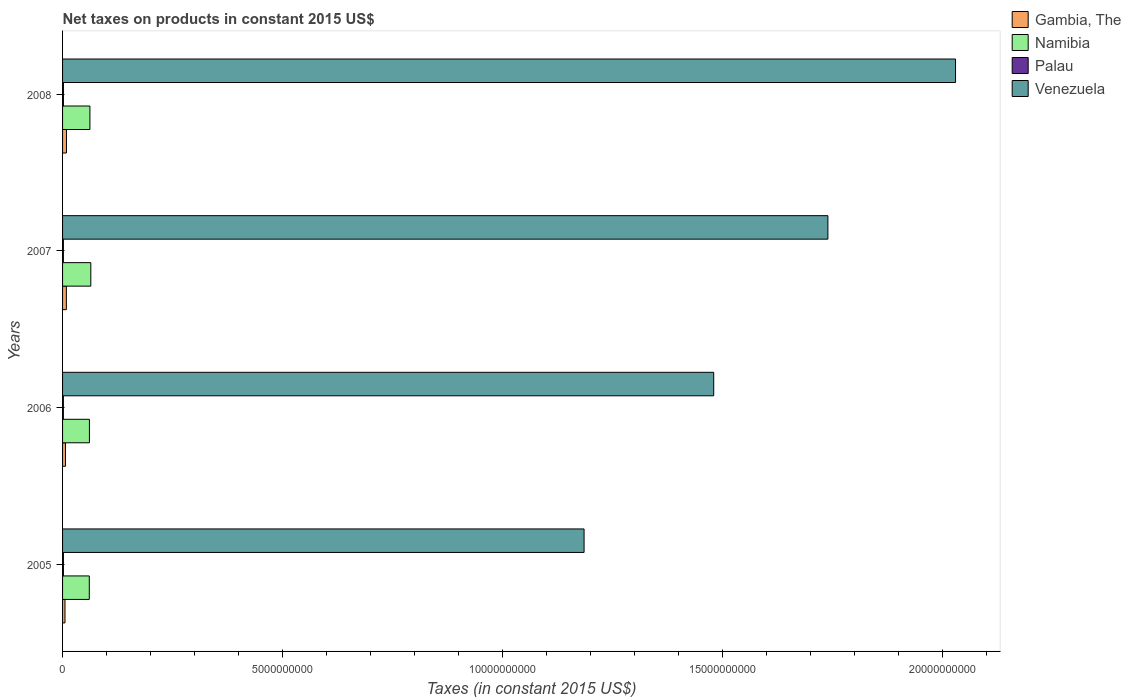How many groups of bars are there?
Ensure brevity in your answer.  4. Are the number of bars per tick equal to the number of legend labels?
Your answer should be very brief. Yes. How many bars are there on the 4th tick from the bottom?
Your answer should be very brief. 4. What is the label of the 2nd group of bars from the top?
Make the answer very short. 2007. What is the net taxes on products in Namibia in 2005?
Offer a very short reply. 6.08e+08. Across all years, what is the maximum net taxes on products in Venezuela?
Offer a terse response. 2.03e+1. Across all years, what is the minimum net taxes on products in Gambia, The?
Make the answer very short. 5.48e+07. What is the total net taxes on products in Gambia, The in the graph?
Offer a very short reply. 2.97e+08. What is the difference between the net taxes on products in Venezuela in 2007 and that in 2008?
Your answer should be compact. -2.90e+09. What is the difference between the net taxes on products in Venezuela in 2006 and the net taxes on products in Namibia in 2007?
Offer a terse response. 1.42e+1. What is the average net taxes on products in Namibia per year?
Keep it short and to the point. 6.20e+08. In the year 2007, what is the difference between the net taxes on products in Gambia, The and net taxes on products in Venezuela?
Give a very brief answer. -1.73e+1. What is the ratio of the net taxes on products in Venezuela in 2006 to that in 2008?
Offer a very short reply. 0.73. What is the difference between the highest and the second highest net taxes on products in Venezuela?
Give a very brief answer. 2.90e+09. What is the difference between the highest and the lowest net taxes on products in Venezuela?
Make the answer very short. 8.44e+09. In how many years, is the net taxes on products in Venezuela greater than the average net taxes on products in Venezuela taken over all years?
Make the answer very short. 2. Is the sum of the net taxes on products in Namibia in 2005 and 2006 greater than the maximum net taxes on products in Venezuela across all years?
Give a very brief answer. No. What does the 1st bar from the top in 2007 represents?
Your answer should be compact. Venezuela. What does the 3rd bar from the bottom in 2005 represents?
Keep it short and to the point. Palau. Is it the case that in every year, the sum of the net taxes on products in Gambia, The and net taxes on products in Palau is greater than the net taxes on products in Venezuela?
Offer a very short reply. No. How many bars are there?
Keep it short and to the point. 16. How many years are there in the graph?
Give a very brief answer. 4. What is the difference between two consecutive major ticks on the X-axis?
Your response must be concise. 5.00e+09. Are the values on the major ticks of X-axis written in scientific E-notation?
Provide a succinct answer. No. Where does the legend appear in the graph?
Provide a short and direct response. Top right. How many legend labels are there?
Offer a very short reply. 4. How are the legend labels stacked?
Provide a succinct answer. Vertical. What is the title of the graph?
Give a very brief answer. Net taxes on products in constant 2015 US$. Does "Jordan" appear as one of the legend labels in the graph?
Provide a short and direct response. No. What is the label or title of the X-axis?
Keep it short and to the point. Taxes (in constant 2015 US$). What is the Taxes (in constant 2015 US$) of Gambia, The in 2005?
Provide a short and direct response. 5.48e+07. What is the Taxes (in constant 2015 US$) of Namibia in 2005?
Make the answer very short. 6.08e+08. What is the Taxes (in constant 2015 US$) of Palau in 2005?
Your answer should be very brief. 1.94e+07. What is the Taxes (in constant 2015 US$) in Venezuela in 2005?
Offer a terse response. 1.19e+1. What is the Taxes (in constant 2015 US$) in Gambia, The in 2006?
Offer a very short reply. 6.61e+07. What is the Taxes (in constant 2015 US$) in Namibia in 2006?
Your answer should be very brief. 6.10e+08. What is the Taxes (in constant 2015 US$) of Palau in 2006?
Ensure brevity in your answer.  1.84e+07. What is the Taxes (in constant 2015 US$) in Venezuela in 2006?
Ensure brevity in your answer.  1.48e+1. What is the Taxes (in constant 2015 US$) in Gambia, The in 2007?
Ensure brevity in your answer.  8.66e+07. What is the Taxes (in constant 2015 US$) of Namibia in 2007?
Make the answer very short. 6.42e+08. What is the Taxes (in constant 2015 US$) of Palau in 2007?
Offer a terse response. 1.86e+07. What is the Taxes (in constant 2015 US$) of Venezuela in 2007?
Provide a succinct answer. 1.74e+1. What is the Taxes (in constant 2015 US$) of Gambia, The in 2008?
Provide a short and direct response. 8.92e+07. What is the Taxes (in constant 2015 US$) of Namibia in 2008?
Your answer should be very brief. 6.22e+08. What is the Taxes (in constant 2015 US$) of Palau in 2008?
Provide a short and direct response. 1.99e+07. What is the Taxes (in constant 2015 US$) in Venezuela in 2008?
Your response must be concise. 2.03e+1. Across all years, what is the maximum Taxes (in constant 2015 US$) in Gambia, The?
Your answer should be compact. 8.92e+07. Across all years, what is the maximum Taxes (in constant 2015 US$) in Namibia?
Offer a very short reply. 6.42e+08. Across all years, what is the maximum Taxes (in constant 2015 US$) of Palau?
Keep it short and to the point. 1.99e+07. Across all years, what is the maximum Taxes (in constant 2015 US$) in Venezuela?
Your response must be concise. 2.03e+1. Across all years, what is the minimum Taxes (in constant 2015 US$) in Gambia, The?
Your response must be concise. 5.48e+07. Across all years, what is the minimum Taxes (in constant 2015 US$) of Namibia?
Make the answer very short. 6.08e+08. Across all years, what is the minimum Taxes (in constant 2015 US$) in Palau?
Make the answer very short. 1.84e+07. Across all years, what is the minimum Taxes (in constant 2015 US$) of Venezuela?
Provide a succinct answer. 1.19e+1. What is the total Taxes (in constant 2015 US$) of Gambia, The in the graph?
Your answer should be compact. 2.97e+08. What is the total Taxes (in constant 2015 US$) in Namibia in the graph?
Offer a terse response. 2.48e+09. What is the total Taxes (in constant 2015 US$) of Palau in the graph?
Offer a very short reply. 7.63e+07. What is the total Taxes (in constant 2015 US$) of Venezuela in the graph?
Offer a terse response. 6.43e+1. What is the difference between the Taxes (in constant 2015 US$) of Gambia, The in 2005 and that in 2006?
Make the answer very short. -1.13e+07. What is the difference between the Taxes (in constant 2015 US$) of Namibia in 2005 and that in 2006?
Offer a very short reply. -2.85e+06. What is the difference between the Taxes (in constant 2015 US$) of Palau in 2005 and that in 2006?
Ensure brevity in your answer.  1.05e+06. What is the difference between the Taxes (in constant 2015 US$) in Venezuela in 2005 and that in 2006?
Ensure brevity in your answer.  -2.95e+09. What is the difference between the Taxes (in constant 2015 US$) in Gambia, The in 2005 and that in 2007?
Offer a terse response. -3.18e+07. What is the difference between the Taxes (in constant 2015 US$) in Namibia in 2005 and that in 2007?
Give a very brief answer. -3.43e+07. What is the difference between the Taxes (in constant 2015 US$) in Palau in 2005 and that in 2007?
Give a very brief answer. 8.20e+05. What is the difference between the Taxes (in constant 2015 US$) in Venezuela in 2005 and that in 2007?
Ensure brevity in your answer.  -5.54e+09. What is the difference between the Taxes (in constant 2015 US$) of Gambia, The in 2005 and that in 2008?
Make the answer very short. -3.44e+07. What is the difference between the Taxes (in constant 2015 US$) in Namibia in 2005 and that in 2008?
Your answer should be compact. -1.43e+07. What is the difference between the Taxes (in constant 2015 US$) in Palau in 2005 and that in 2008?
Give a very brief answer. -4.28e+05. What is the difference between the Taxes (in constant 2015 US$) in Venezuela in 2005 and that in 2008?
Make the answer very short. -8.44e+09. What is the difference between the Taxes (in constant 2015 US$) of Gambia, The in 2006 and that in 2007?
Your answer should be compact. -2.05e+07. What is the difference between the Taxes (in constant 2015 US$) in Namibia in 2006 and that in 2007?
Offer a very short reply. -3.14e+07. What is the difference between the Taxes (in constant 2015 US$) in Palau in 2006 and that in 2007?
Give a very brief answer. -2.35e+05. What is the difference between the Taxes (in constant 2015 US$) in Venezuela in 2006 and that in 2007?
Give a very brief answer. -2.60e+09. What is the difference between the Taxes (in constant 2015 US$) in Gambia, The in 2006 and that in 2008?
Give a very brief answer. -2.31e+07. What is the difference between the Taxes (in constant 2015 US$) in Namibia in 2006 and that in 2008?
Your answer should be compact. -1.14e+07. What is the difference between the Taxes (in constant 2015 US$) of Palau in 2006 and that in 2008?
Your answer should be very brief. -1.48e+06. What is the difference between the Taxes (in constant 2015 US$) of Venezuela in 2006 and that in 2008?
Your answer should be very brief. -5.50e+09. What is the difference between the Taxes (in constant 2015 US$) of Gambia, The in 2007 and that in 2008?
Provide a short and direct response. -2.59e+06. What is the difference between the Taxes (in constant 2015 US$) in Namibia in 2007 and that in 2008?
Keep it short and to the point. 2.00e+07. What is the difference between the Taxes (in constant 2015 US$) of Palau in 2007 and that in 2008?
Make the answer very short. -1.25e+06. What is the difference between the Taxes (in constant 2015 US$) of Venezuela in 2007 and that in 2008?
Provide a succinct answer. -2.90e+09. What is the difference between the Taxes (in constant 2015 US$) in Gambia, The in 2005 and the Taxes (in constant 2015 US$) in Namibia in 2006?
Provide a succinct answer. -5.56e+08. What is the difference between the Taxes (in constant 2015 US$) of Gambia, The in 2005 and the Taxes (in constant 2015 US$) of Palau in 2006?
Offer a terse response. 3.65e+07. What is the difference between the Taxes (in constant 2015 US$) of Gambia, The in 2005 and the Taxes (in constant 2015 US$) of Venezuela in 2006?
Make the answer very short. -1.47e+1. What is the difference between the Taxes (in constant 2015 US$) in Namibia in 2005 and the Taxes (in constant 2015 US$) in Palau in 2006?
Offer a terse response. 5.89e+08. What is the difference between the Taxes (in constant 2015 US$) of Namibia in 2005 and the Taxes (in constant 2015 US$) of Venezuela in 2006?
Offer a very short reply. -1.42e+1. What is the difference between the Taxes (in constant 2015 US$) in Palau in 2005 and the Taxes (in constant 2015 US$) in Venezuela in 2006?
Your response must be concise. -1.48e+1. What is the difference between the Taxes (in constant 2015 US$) in Gambia, The in 2005 and the Taxes (in constant 2015 US$) in Namibia in 2007?
Your answer should be very brief. -5.87e+08. What is the difference between the Taxes (in constant 2015 US$) in Gambia, The in 2005 and the Taxes (in constant 2015 US$) in Palau in 2007?
Your answer should be compact. 3.62e+07. What is the difference between the Taxes (in constant 2015 US$) of Gambia, The in 2005 and the Taxes (in constant 2015 US$) of Venezuela in 2007?
Your answer should be compact. -1.73e+1. What is the difference between the Taxes (in constant 2015 US$) of Namibia in 2005 and the Taxes (in constant 2015 US$) of Palau in 2007?
Offer a very short reply. 5.89e+08. What is the difference between the Taxes (in constant 2015 US$) in Namibia in 2005 and the Taxes (in constant 2015 US$) in Venezuela in 2007?
Ensure brevity in your answer.  -1.68e+1. What is the difference between the Taxes (in constant 2015 US$) of Palau in 2005 and the Taxes (in constant 2015 US$) of Venezuela in 2007?
Provide a succinct answer. -1.74e+1. What is the difference between the Taxes (in constant 2015 US$) in Gambia, The in 2005 and the Taxes (in constant 2015 US$) in Namibia in 2008?
Your answer should be very brief. -5.67e+08. What is the difference between the Taxes (in constant 2015 US$) of Gambia, The in 2005 and the Taxes (in constant 2015 US$) of Palau in 2008?
Offer a terse response. 3.50e+07. What is the difference between the Taxes (in constant 2015 US$) in Gambia, The in 2005 and the Taxes (in constant 2015 US$) in Venezuela in 2008?
Ensure brevity in your answer.  -2.02e+1. What is the difference between the Taxes (in constant 2015 US$) in Namibia in 2005 and the Taxes (in constant 2015 US$) in Palau in 2008?
Your response must be concise. 5.88e+08. What is the difference between the Taxes (in constant 2015 US$) in Namibia in 2005 and the Taxes (in constant 2015 US$) in Venezuela in 2008?
Give a very brief answer. -1.97e+1. What is the difference between the Taxes (in constant 2015 US$) of Palau in 2005 and the Taxes (in constant 2015 US$) of Venezuela in 2008?
Keep it short and to the point. -2.03e+1. What is the difference between the Taxes (in constant 2015 US$) of Gambia, The in 2006 and the Taxes (in constant 2015 US$) of Namibia in 2007?
Your answer should be very brief. -5.76e+08. What is the difference between the Taxes (in constant 2015 US$) in Gambia, The in 2006 and the Taxes (in constant 2015 US$) in Palau in 2007?
Keep it short and to the point. 4.75e+07. What is the difference between the Taxes (in constant 2015 US$) of Gambia, The in 2006 and the Taxes (in constant 2015 US$) of Venezuela in 2007?
Offer a very short reply. -1.73e+1. What is the difference between the Taxes (in constant 2015 US$) in Namibia in 2006 and the Taxes (in constant 2015 US$) in Palau in 2007?
Give a very brief answer. 5.92e+08. What is the difference between the Taxes (in constant 2015 US$) in Namibia in 2006 and the Taxes (in constant 2015 US$) in Venezuela in 2007?
Provide a succinct answer. -1.68e+1. What is the difference between the Taxes (in constant 2015 US$) of Palau in 2006 and the Taxes (in constant 2015 US$) of Venezuela in 2007?
Provide a short and direct response. -1.74e+1. What is the difference between the Taxes (in constant 2015 US$) of Gambia, The in 2006 and the Taxes (in constant 2015 US$) of Namibia in 2008?
Keep it short and to the point. -5.56e+08. What is the difference between the Taxes (in constant 2015 US$) of Gambia, The in 2006 and the Taxes (in constant 2015 US$) of Palau in 2008?
Give a very brief answer. 4.63e+07. What is the difference between the Taxes (in constant 2015 US$) of Gambia, The in 2006 and the Taxes (in constant 2015 US$) of Venezuela in 2008?
Your answer should be compact. -2.02e+1. What is the difference between the Taxes (in constant 2015 US$) of Namibia in 2006 and the Taxes (in constant 2015 US$) of Palau in 2008?
Make the answer very short. 5.91e+08. What is the difference between the Taxes (in constant 2015 US$) of Namibia in 2006 and the Taxes (in constant 2015 US$) of Venezuela in 2008?
Give a very brief answer. -1.97e+1. What is the difference between the Taxes (in constant 2015 US$) of Palau in 2006 and the Taxes (in constant 2015 US$) of Venezuela in 2008?
Offer a very short reply. -2.03e+1. What is the difference between the Taxes (in constant 2015 US$) of Gambia, The in 2007 and the Taxes (in constant 2015 US$) of Namibia in 2008?
Ensure brevity in your answer.  -5.35e+08. What is the difference between the Taxes (in constant 2015 US$) in Gambia, The in 2007 and the Taxes (in constant 2015 US$) in Palau in 2008?
Your response must be concise. 6.67e+07. What is the difference between the Taxes (in constant 2015 US$) in Gambia, The in 2007 and the Taxes (in constant 2015 US$) in Venezuela in 2008?
Your answer should be compact. -2.02e+1. What is the difference between the Taxes (in constant 2015 US$) of Namibia in 2007 and the Taxes (in constant 2015 US$) of Palau in 2008?
Keep it short and to the point. 6.22e+08. What is the difference between the Taxes (in constant 2015 US$) in Namibia in 2007 and the Taxes (in constant 2015 US$) in Venezuela in 2008?
Your answer should be very brief. -1.97e+1. What is the difference between the Taxes (in constant 2015 US$) in Palau in 2007 and the Taxes (in constant 2015 US$) in Venezuela in 2008?
Make the answer very short. -2.03e+1. What is the average Taxes (in constant 2015 US$) in Gambia, The per year?
Keep it short and to the point. 7.42e+07. What is the average Taxes (in constant 2015 US$) of Namibia per year?
Keep it short and to the point. 6.20e+08. What is the average Taxes (in constant 2015 US$) in Palau per year?
Your answer should be very brief. 1.91e+07. What is the average Taxes (in constant 2015 US$) of Venezuela per year?
Provide a succinct answer. 1.61e+1. In the year 2005, what is the difference between the Taxes (in constant 2015 US$) of Gambia, The and Taxes (in constant 2015 US$) of Namibia?
Offer a very short reply. -5.53e+08. In the year 2005, what is the difference between the Taxes (in constant 2015 US$) in Gambia, The and Taxes (in constant 2015 US$) in Palau?
Provide a short and direct response. 3.54e+07. In the year 2005, what is the difference between the Taxes (in constant 2015 US$) of Gambia, The and Taxes (in constant 2015 US$) of Venezuela?
Make the answer very short. -1.18e+1. In the year 2005, what is the difference between the Taxes (in constant 2015 US$) of Namibia and Taxes (in constant 2015 US$) of Palau?
Give a very brief answer. 5.88e+08. In the year 2005, what is the difference between the Taxes (in constant 2015 US$) in Namibia and Taxes (in constant 2015 US$) in Venezuela?
Make the answer very short. -1.12e+1. In the year 2005, what is the difference between the Taxes (in constant 2015 US$) of Palau and Taxes (in constant 2015 US$) of Venezuela?
Offer a terse response. -1.18e+1. In the year 2006, what is the difference between the Taxes (in constant 2015 US$) in Gambia, The and Taxes (in constant 2015 US$) in Namibia?
Make the answer very short. -5.44e+08. In the year 2006, what is the difference between the Taxes (in constant 2015 US$) of Gambia, The and Taxes (in constant 2015 US$) of Palau?
Offer a terse response. 4.78e+07. In the year 2006, what is the difference between the Taxes (in constant 2015 US$) of Gambia, The and Taxes (in constant 2015 US$) of Venezuela?
Give a very brief answer. -1.47e+1. In the year 2006, what is the difference between the Taxes (in constant 2015 US$) in Namibia and Taxes (in constant 2015 US$) in Palau?
Offer a terse response. 5.92e+08. In the year 2006, what is the difference between the Taxes (in constant 2015 US$) of Namibia and Taxes (in constant 2015 US$) of Venezuela?
Your answer should be very brief. -1.42e+1. In the year 2006, what is the difference between the Taxes (in constant 2015 US$) in Palau and Taxes (in constant 2015 US$) in Venezuela?
Provide a short and direct response. -1.48e+1. In the year 2007, what is the difference between the Taxes (in constant 2015 US$) in Gambia, The and Taxes (in constant 2015 US$) in Namibia?
Offer a terse response. -5.55e+08. In the year 2007, what is the difference between the Taxes (in constant 2015 US$) of Gambia, The and Taxes (in constant 2015 US$) of Palau?
Keep it short and to the point. 6.80e+07. In the year 2007, what is the difference between the Taxes (in constant 2015 US$) of Gambia, The and Taxes (in constant 2015 US$) of Venezuela?
Provide a succinct answer. -1.73e+1. In the year 2007, what is the difference between the Taxes (in constant 2015 US$) of Namibia and Taxes (in constant 2015 US$) of Palau?
Your answer should be compact. 6.23e+08. In the year 2007, what is the difference between the Taxes (in constant 2015 US$) of Namibia and Taxes (in constant 2015 US$) of Venezuela?
Provide a short and direct response. -1.68e+1. In the year 2007, what is the difference between the Taxes (in constant 2015 US$) in Palau and Taxes (in constant 2015 US$) in Venezuela?
Keep it short and to the point. -1.74e+1. In the year 2008, what is the difference between the Taxes (in constant 2015 US$) of Gambia, The and Taxes (in constant 2015 US$) of Namibia?
Make the answer very short. -5.33e+08. In the year 2008, what is the difference between the Taxes (in constant 2015 US$) in Gambia, The and Taxes (in constant 2015 US$) in Palau?
Offer a very short reply. 6.93e+07. In the year 2008, what is the difference between the Taxes (in constant 2015 US$) of Gambia, The and Taxes (in constant 2015 US$) of Venezuela?
Ensure brevity in your answer.  -2.02e+1. In the year 2008, what is the difference between the Taxes (in constant 2015 US$) in Namibia and Taxes (in constant 2015 US$) in Palau?
Provide a succinct answer. 6.02e+08. In the year 2008, what is the difference between the Taxes (in constant 2015 US$) in Namibia and Taxes (in constant 2015 US$) in Venezuela?
Make the answer very short. -1.97e+1. In the year 2008, what is the difference between the Taxes (in constant 2015 US$) in Palau and Taxes (in constant 2015 US$) in Venezuela?
Offer a terse response. -2.03e+1. What is the ratio of the Taxes (in constant 2015 US$) of Gambia, The in 2005 to that in 2006?
Give a very brief answer. 0.83. What is the ratio of the Taxes (in constant 2015 US$) in Namibia in 2005 to that in 2006?
Offer a terse response. 1. What is the ratio of the Taxes (in constant 2015 US$) in Palau in 2005 to that in 2006?
Keep it short and to the point. 1.06. What is the ratio of the Taxes (in constant 2015 US$) in Venezuela in 2005 to that in 2006?
Give a very brief answer. 0.8. What is the ratio of the Taxes (in constant 2015 US$) of Gambia, The in 2005 to that in 2007?
Provide a short and direct response. 0.63. What is the ratio of the Taxes (in constant 2015 US$) of Namibia in 2005 to that in 2007?
Provide a succinct answer. 0.95. What is the ratio of the Taxes (in constant 2015 US$) of Palau in 2005 to that in 2007?
Ensure brevity in your answer.  1.04. What is the ratio of the Taxes (in constant 2015 US$) in Venezuela in 2005 to that in 2007?
Your answer should be compact. 0.68. What is the ratio of the Taxes (in constant 2015 US$) in Gambia, The in 2005 to that in 2008?
Your response must be concise. 0.61. What is the ratio of the Taxes (in constant 2015 US$) of Palau in 2005 to that in 2008?
Your answer should be very brief. 0.98. What is the ratio of the Taxes (in constant 2015 US$) in Venezuela in 2005 to that in 2008?
Your answer should be compact. 0.58. What is the ratio of the Taxes (in constant 2015 US$) in Gambia, The in 2006 to that in 2007?
Provide a short and direct response. 0.76. What is the ratio of the Taxes (in constant 2015 US$) of Namibia in 2006 to that in 2007?
Ensure brevity in your answer.  0.95. What is the ratio of the Taxes (in constant 2015 US$) of Palau in 2006 to that in 2007?
Provide a short and direct response. 0.99. What is the ratio of the Taxes (in constant 2015 US$) of Venezuela in 2006 to that in 2007?
Provide a short and direct response. 0.85. What is the ratio of the Taxes (in constant 2015 US$) of Gambia, The in 2006 to that in 2008?
Your response must be concise. 0.74. What is the ratio of the Taxes (in constant 2015 US$) of Namibia in 2006 to that in 2008?
Provide a short and direct response. 0.98. What is the ratio of the Taxes (in constant 2015 US$) of Palau in 2006 to that in 2008?
Provide a succinct answer. 0.93. What is the ratio of the Taxes (in constant 2015 US$) of Venezuela in 2006 to that in 2008?
Give a very brief answer. 0.73. What is the ratio of the Taxes (in constant 2015 US$) of Gambia, The in 2007 to that in 2008?
Provide a short and direct response. 0.97. What is the ratio of the Taxes (in constant 2015 US$) of Namibia in 2007 to that in 2008?
Give a very brief answer. 1.03. What is the ratio of the Taxes (in constant 2015 US$) in Palau in 2007 to that in 2008?
Give a very brief answer. 0.94. What is the difference between the highest and the second highest Taxes (in constant 2015 US$) in Gambia, The?
Offer a terse response. 2.59e+06. What is the difference between the highest and the second highest Taxes (in constant 2015 US$) of Namibia?
Offer a terse response. 2.00e+07. What is the difference between the highest and the second highest Taxes (in constant 2015 US$) in Palau?
Offer a terse response. 4.28e+05. What is the difference between the highest and the second highest Taxes (in constant 2015 US$) of Venezuela?
Provide a short and direct response. 2.90e+09. What is the difference between the highest and the lowest Taxes (in constant 2015 US$) in Gambia, The?
Provide a succinct answer. 3.44e+07. What is the difference between the highest and the lowest Taxes (in constant 2015 US$) in Namibia?
Your answer should be compact. 3.43e+07. What is the difference between the highest and the lowest Taxes (in constant 2015 US$) in Palau?
Offer a terse response. 1.48e+06. What is the difference between the highest and the lowest Taxes (in constant 2015 US$) in Venezuela?
Provide a short and direct response. 8.44e+09. 